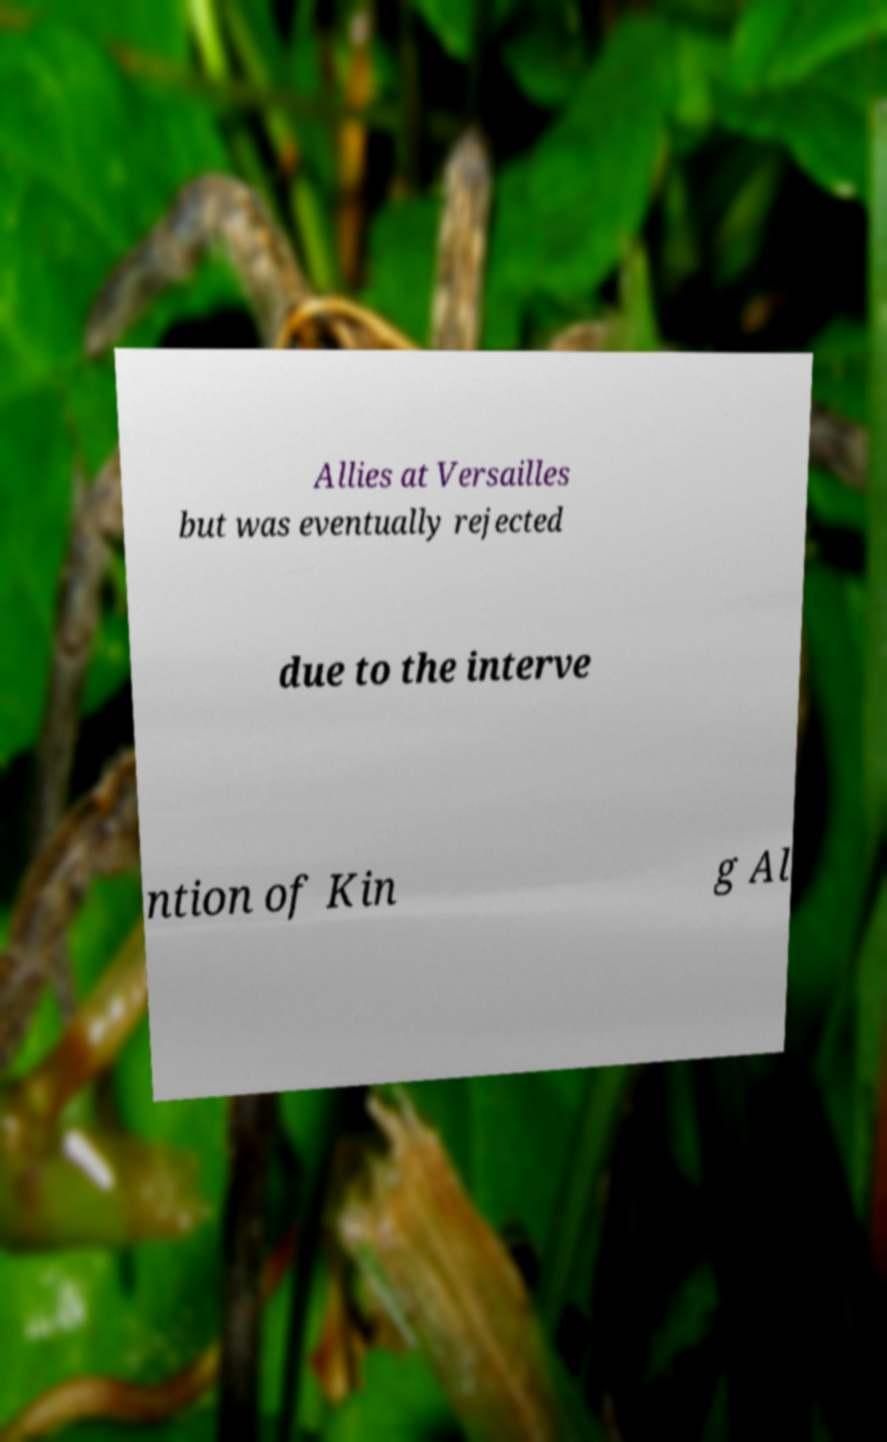What messages or text are displayed in this image? I need them in a readable, typed format. Allies at Versailles but was eventually rejected due to the interve ntion of Kin g Al 